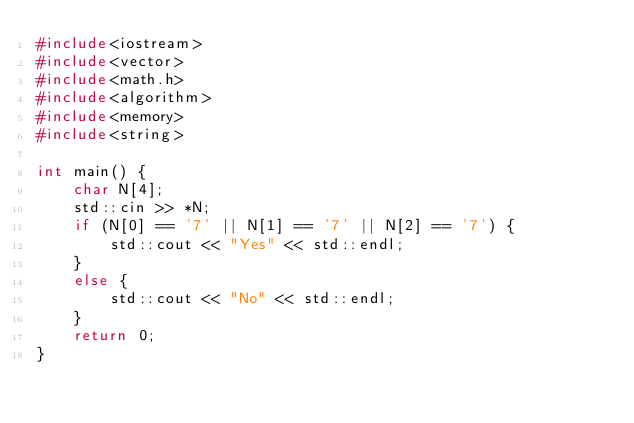Convert code to text. <code><loc_0><loc_0><loc_500><loc_500><_C_>#include<iostream>
#include<vector>
#include<math.h>
#include<algorithm>
#include<memory>
#include<string>

int main() {
	char N[4];
	std::cin >> *N;
	if (N[0] == '7' || N[1] == '7' || N[2] == '7') {
		std::cout << "Yes" << std::endl;
	}
	else {
		std::cout << "No" << std::endl;
	}
	return 0;
}</code> 